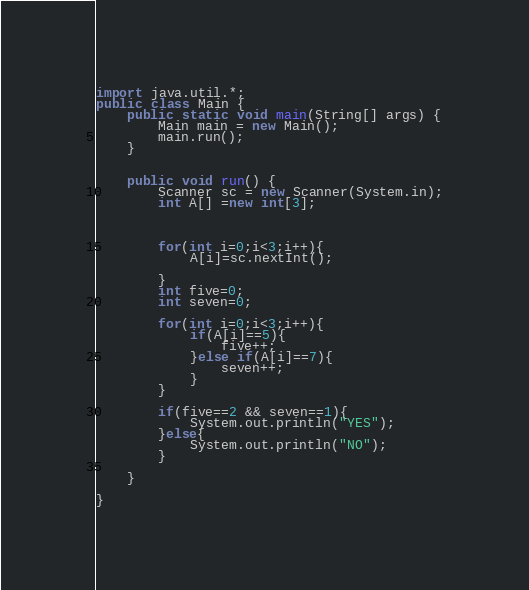<code> <loc_0><loc_0><loc_500><loc_500><_Java_>import java.util.*;
public class Main {
	public static void main(String[] args) {
		Main main = new Main();
		main.run();
	}
 
 
	public void run() {
		Scanner sc = new Scanner(System.in);
		int A[] =new int[3];
        
        
        
        for(int i=0;i<3;i++){
            A[i]=sc.nextInt();
            
        }
		int five=0;
		int seven=0;
		
		for(int i=0;i<3;i++){
		    if(A[i]==5){
		        five++;
		    }else if(A[i]==7){
		        seven++;
		    }
		}
		
		if(five==2 && seven==1){
		    System.out.println("YES");
		}else{
		    System.out.println("NO");
		}
		
	}
		
}
</code> 